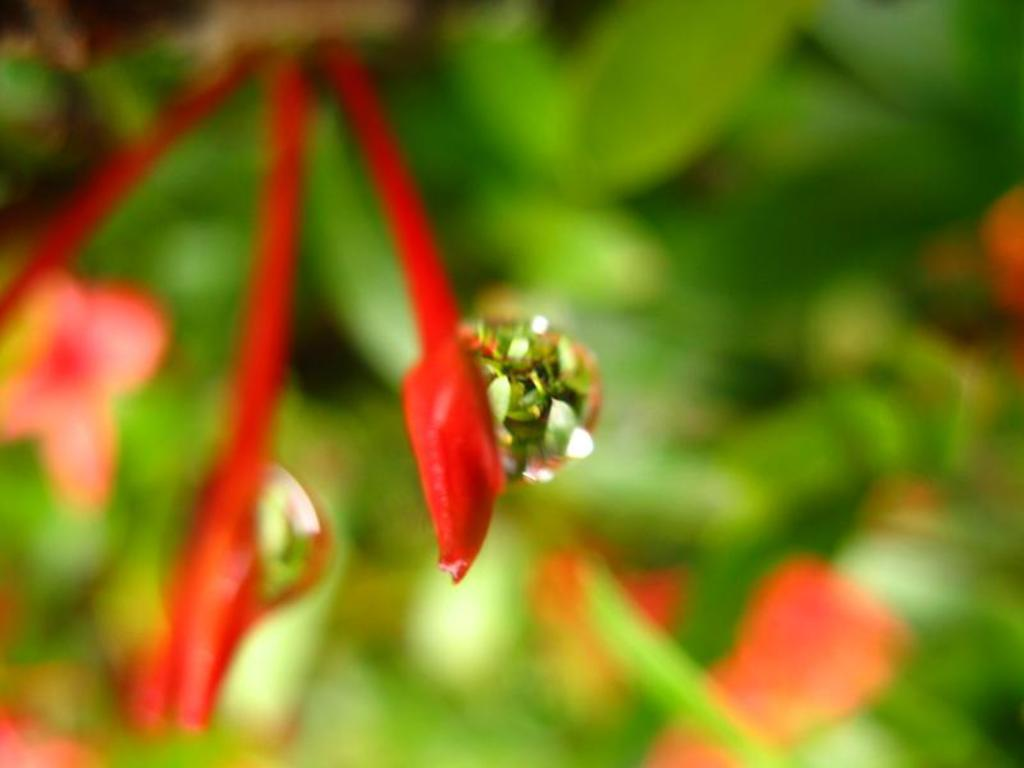What is present on the buds of the plant in the image? There are water drops on the buds of the plant. Can you describe the background of the image? The background of the image is blurred. What type of hat is the person wearing while driving in the image? There is no person or driving activity present in the image; it features a plant with water drops on its buds and a blurred background. 